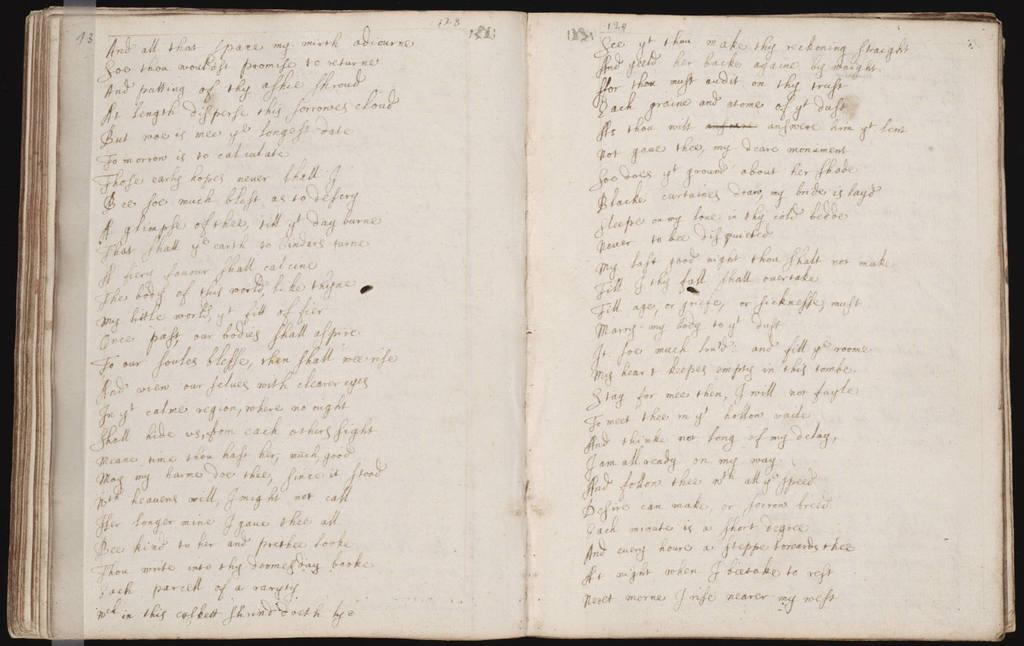Provide a one-sentence caption for the provided image. The book is opened to page 13 displayed at the top left corner. 